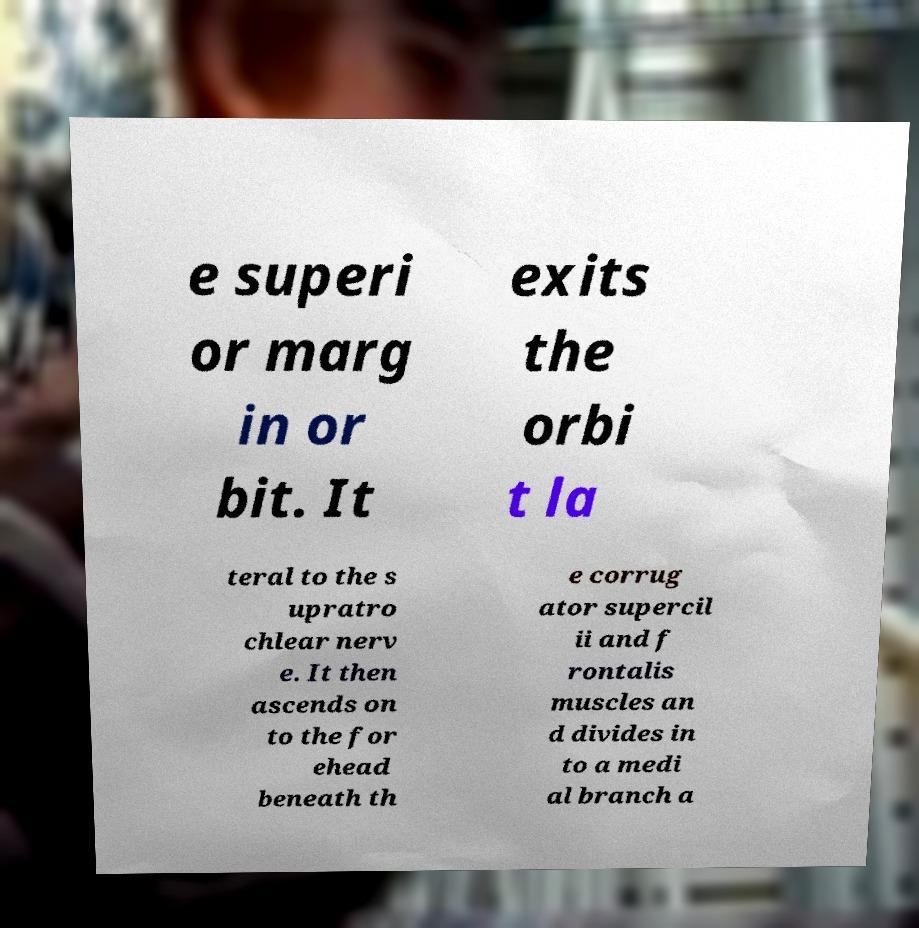What messages or text are displayed in this image? I need them in a readable, typed format. e superi or marg in or bit. It exits the orbi t la teral to the s upratro chlear nerv e. It then ascends on to the for ehead beneath th e corrug ator supercil ii and f rontalis muscles an d divides in to a medi al branch a 